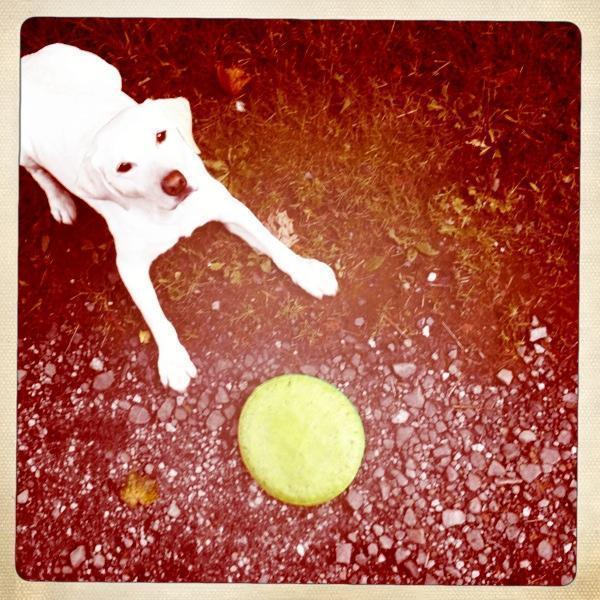How many dogs?
Give a very brief answer. 1. 